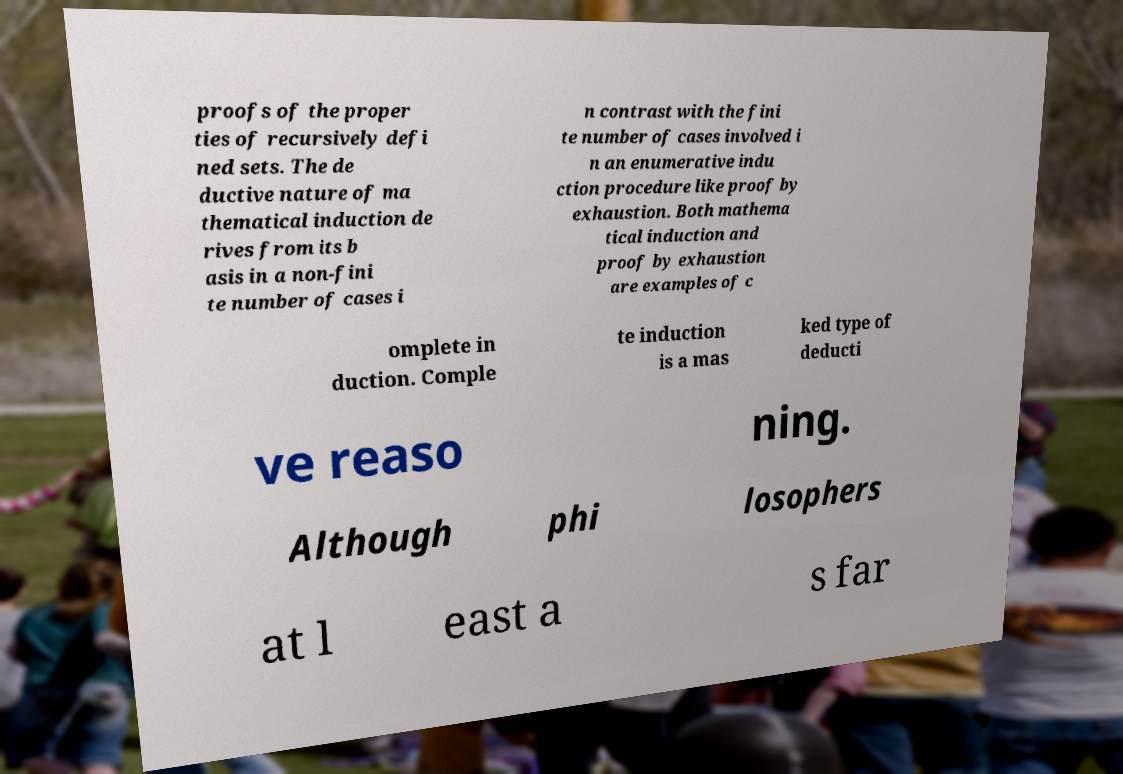For documentation purposes, I need the text within this image transcribed. Could you provide that? proofs of the proper ties of recursively defi ned sets. The de ductive nature of ma thematical induction de rives from its b asis in a non-fini te number of cases i n contrast with the fini te number of cases involved i n an enumerative indu ction procedure like proof by exhaustion. Both mathema tical induction and proof by exhaustion are examples of c omplete in duction. Comple te induction is a mas ked type of deducti ve reaso ning. Although phi losophers at l east a s far 